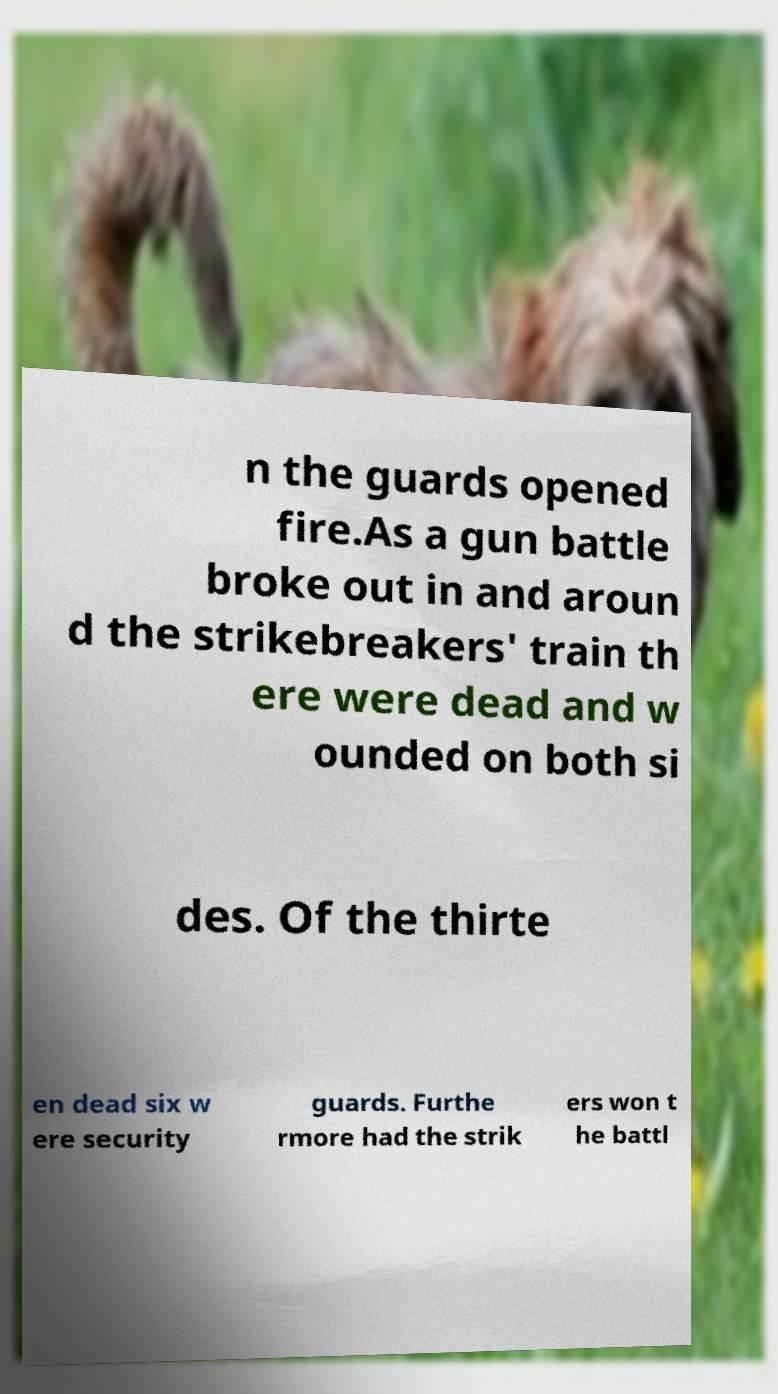For documentation purposes, I need the text within this image transcribed. Could you provide that? n the guards opened fire.As a gun battle broke out in and aroun d the strikebreakers' train th ere were dead and w ounded on both si des. Of the thirte en dead six w ere security guards. Furthe rmore had the strik ers won t he battl 